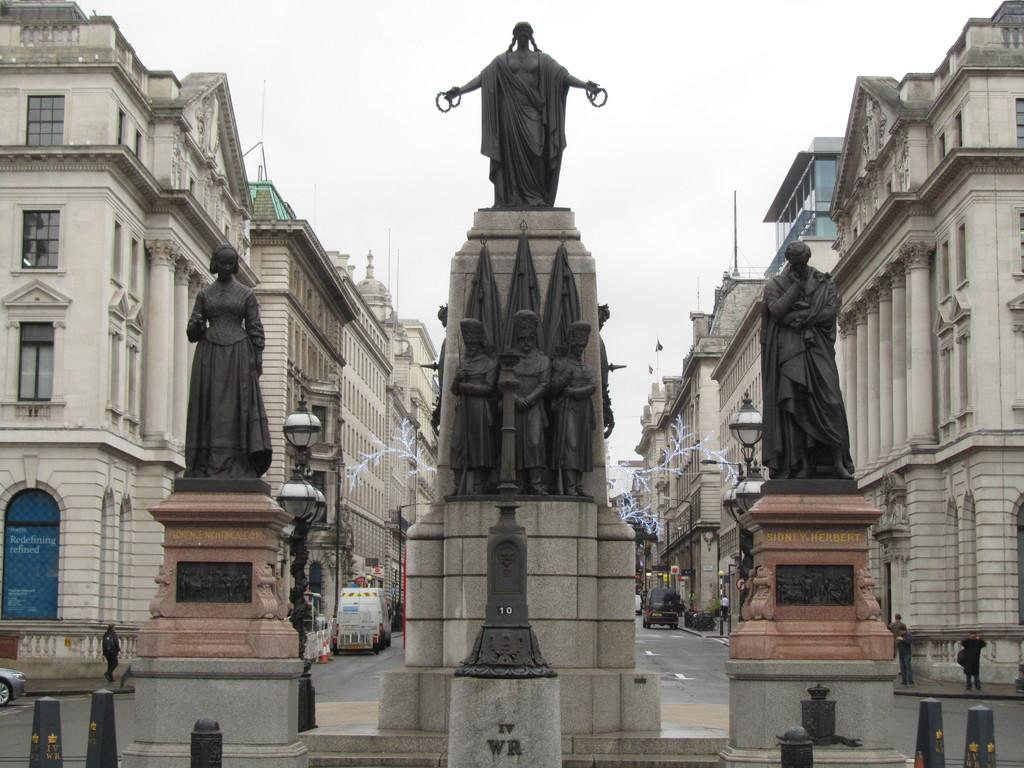What type of objects can be seen in the image? There are statues, vehicles, and buildings in the image. Where are the buildings located in the image? There are buildings on both the left and right sides of the image. What is the primary mode of transportation visible in the image? Vehicles can be seen on the road in the image. What type of skirt is the snake wearing in the image? There is no snake or skirt present in the image. 